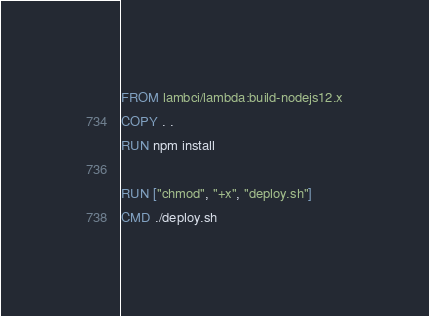Convert code to text. <code><loc_0><loc_0><loc_500><loc_500><_Dockerfile_>FROM lambci/lambda:build-nodejs12.x
COPY . .
RUN npm install

RUN ["chmod", "+x", "deploy.sh"]
CMD ./deploy.sh</code> 